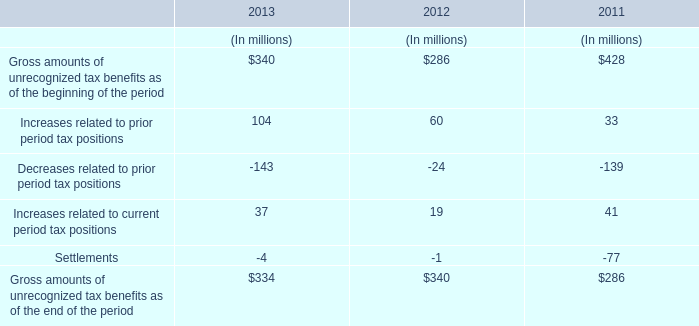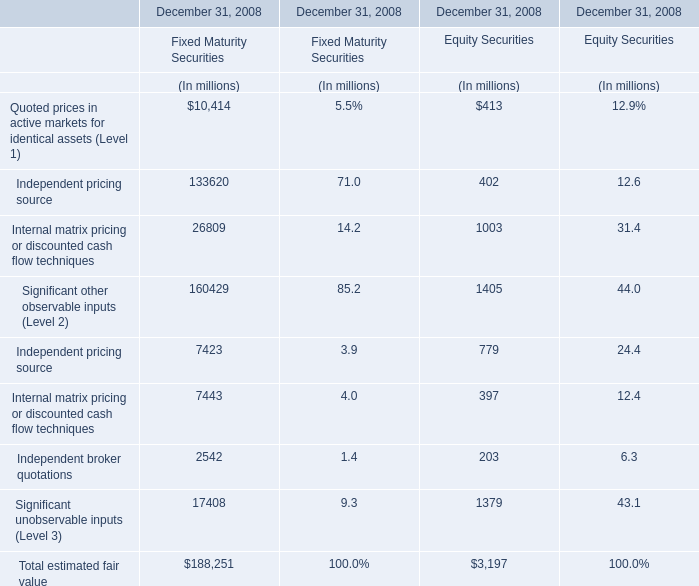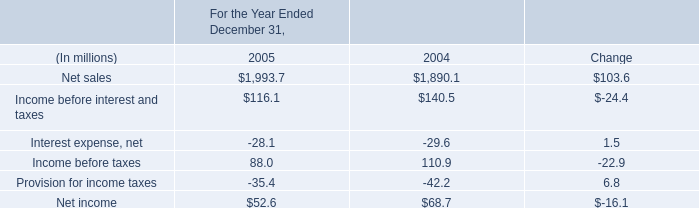What is the sum of Equity Securities in the range of 700 and 2000 in 2008? (in million) 
Computations: (1003 + 779)
Answer: 1782.0. 